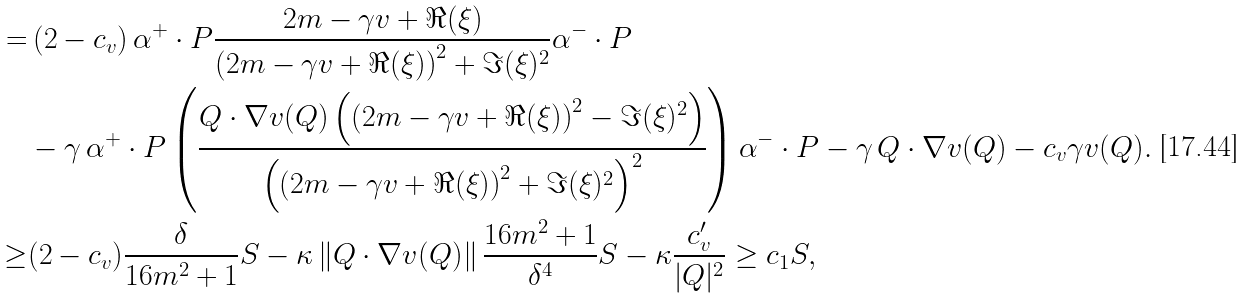Convert formula to latex. <formula><loc_0><loc_0><loc_500><loc_500>= & \, ( 2 - c _ { v } ) \, \alpha ^ { + } \cdot P \frac { 2 m - \gamma v + \Re ( \xi ) } { \left ( 2 m - \gamma v + \Re ( \xi ) \right ) ^ { 2 } + \Im ( \xi ) ^ { 2 } } \alpha ^ { - } \cdot P \\ & - \gamma \, \alpha ^ { + } \cdot P \left ( \frac { Q \cdot \nabla v ( Q ) \left ( \left ( 2 m - \gamma v + \Re ( \xi ) \right ) ^ { 2 } - \Im ( \xi ) ^ { 2 } \right ) } { \left ( \left ( 2 m - \gamma v + \Re ( \xi ) \right ) ^ { 2 } + \Im ( \xi ) ^ { 2 } \right ) ^ { 2 } } \right ) \alpha ^ { - } \cdot P - \gamma \, Q \cdot \nabla v ( Q ) - c _ { v } \gamma v ( Q ) . \\ \geq & ( 2 - c _ { v } ) \frac { \delta } { 1 6 m ^ { 2 } + 1 } S - \kappa \, \| Q \cdot \nabla v ( Q ) \| \, \frac { 1 6 m ^ { 2 } + 1 } { \delta ^ { 4 } } S - \kappa \frac { c _ { v } ^ { \prime } } { | Q | ^ { 2 } } \geq c _ { 1 } S ,</formula> 